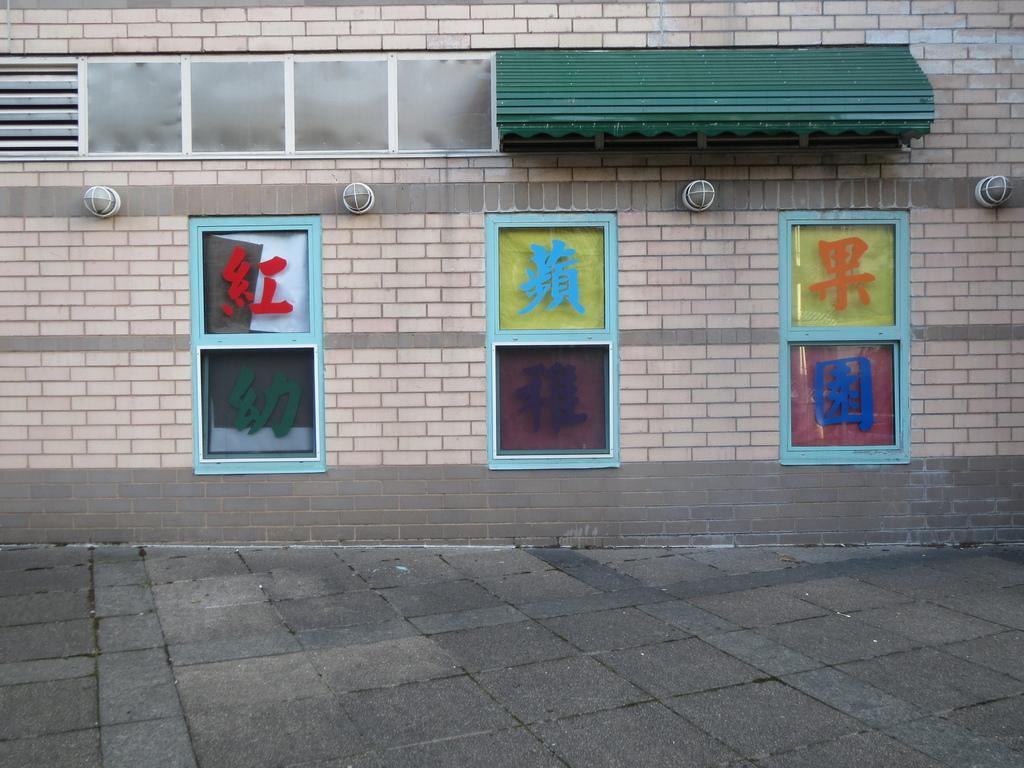What is the main structure visible in the image? There is a wall in the image. What feature can be seen on the wall? There are windows on the wall. What is located at the top of the image? There are sheds at the top of the image. What is the price of the statement in the image? There is no price, statement, or adjustment present in the image. 